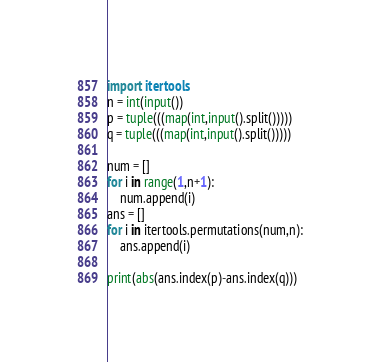<code> <loc_0><loc_0><loc_500><loc_500><_Python_>import itertools
n = int(input())
p = tuple(((map(int,input().split()))))
q = tuple(((map(int,input().split()))))

num = []
for i in range(1,n+1):
    num.append(i)
ans = []
for i in itertools.permutations(num,n):
    ans.append(i)

print(abs(ans.index(p)-ans.index(q)))
</code> 